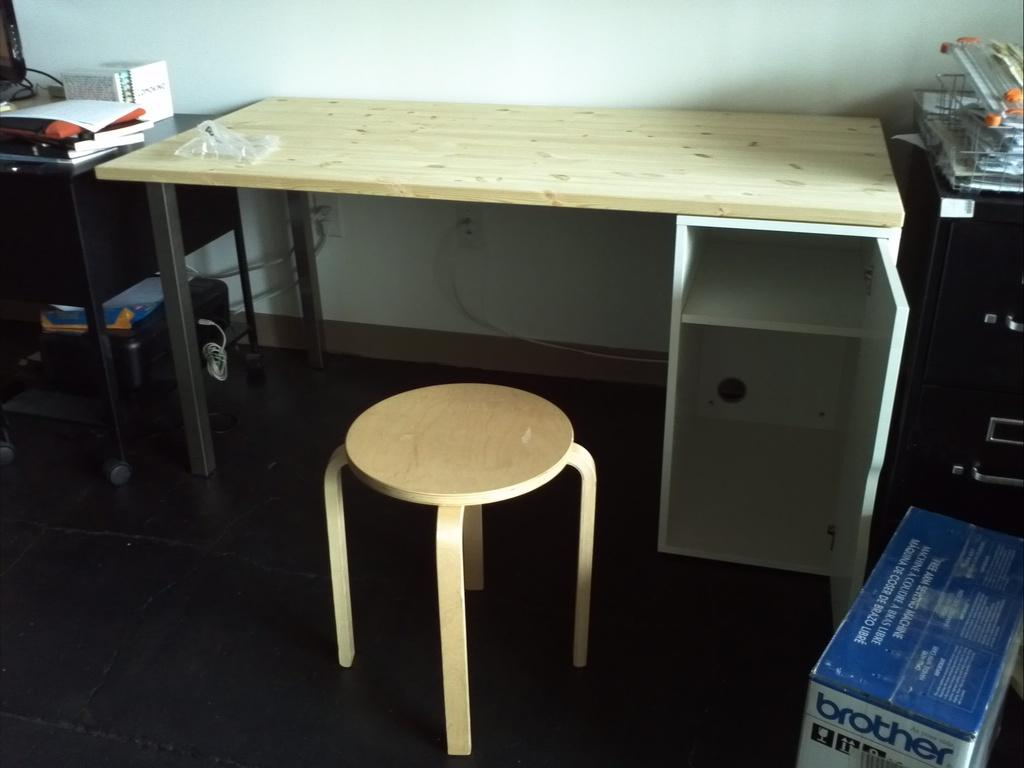<image>
Render a clear and concise summary of the photo. a blue and white box in an office with the word brother on it 